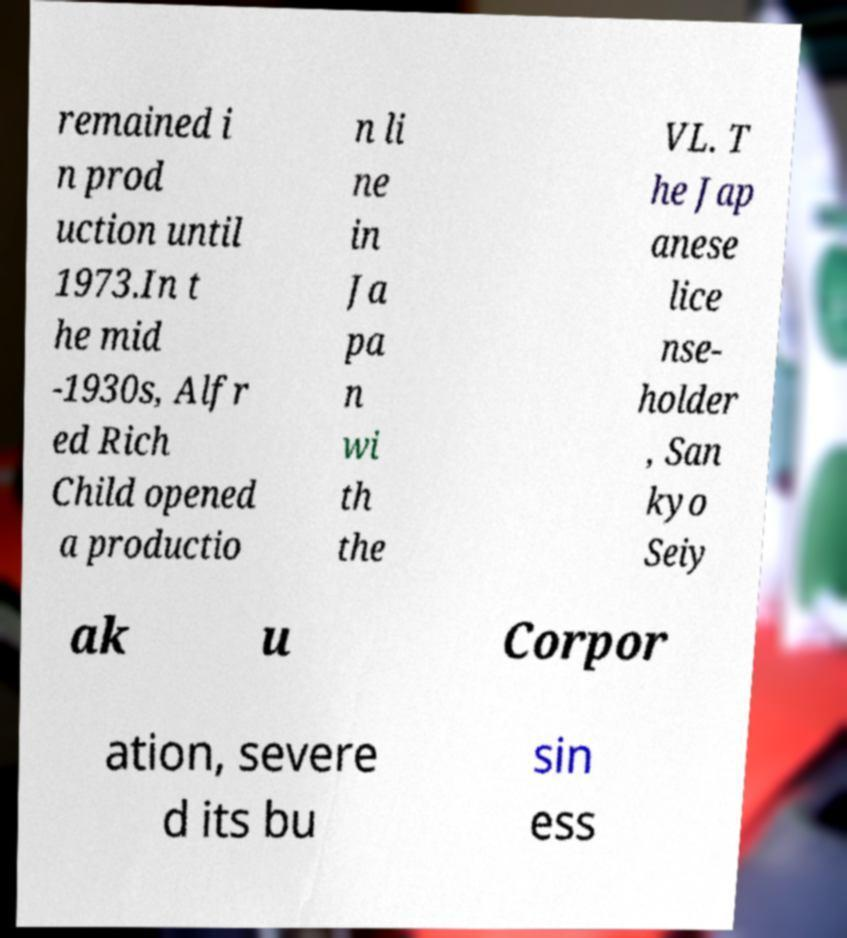Please identify and transcribe the text found in this image. remained i n prod uction until 1973.In t he mid -1930s, Alfr ed Rich Child opened a productio n li ne in Ja pa n wi th the VL. T he Jap anese lice nse- holder , San kyo Seiy ak u Corpor ation, severe d its bu sin ess 